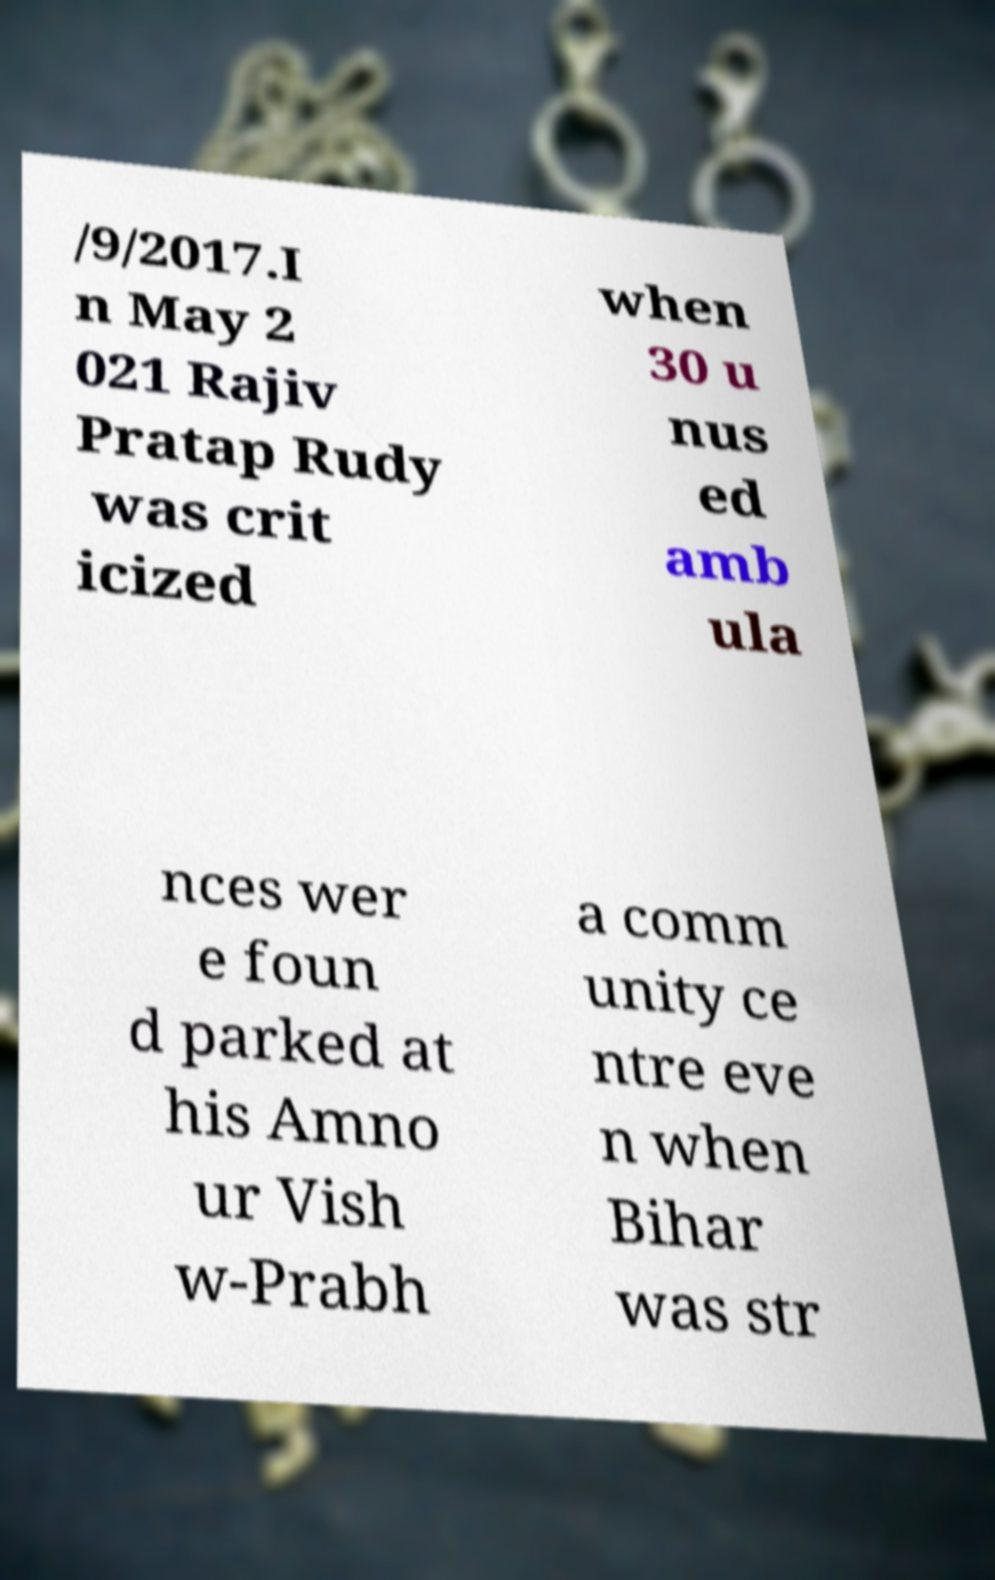What messages or text are displayed in this image? I need them in a readable, typed format. /9/2017.I n May 2 021 Rajiv Pratap Rudy was crit icized when 30 u nus ed amb ula nces wer e foun d parked at his Amno ur Vish w-Prabh a comm unity ce ntre eve n when Bihar was str 